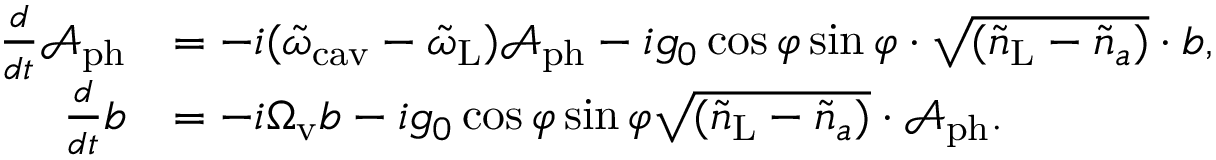Convert formula to latex. <formula><loc_0><loc_0><loc_500><loc_500>\begin{array} { r l } { \frac { d } { d t } \mathcal { A } _ { p h } } & { = - i ( \tilde { \omega } _ { c a v } - \tilde { \omega } _ { L } ) \mathcal { A } _ { p h } - i g _ { 0 } \cos \varphi \sin \varphi \cdot \sqrt { ( \tilde { n } _ { L } - \tilde { n } _ { a } ) } \cdot b , } \\ { \frac { d } { d t } b } & { = - i \Omega _ { v } b - i g _ { 0 } \cos \varphi \sin \varphi \sqrt { ( \tilde { n } _ { L } - \tilde { n } _ { a } ) } \cdot \mathcal { A } _ { p h } . } \end{array}</formula> 